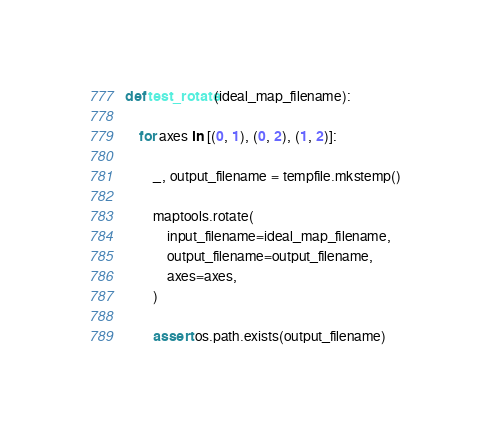Convert code to text. <code><loc_0><loc_0><loc_500><loc_500><_Python_>
def test_rotate(ideal_map_filename):

    for axes in [(0, 1), (0, 2), (1, 2)]:

        _, output_filename = tempfile.mkstemp()

        maptools.rotate(
            input_filename=ideal_map_filename,
            output_filename=output_filename,
            axes=axes,
        )

        assert os.path.exists(output_filename)
</code> 